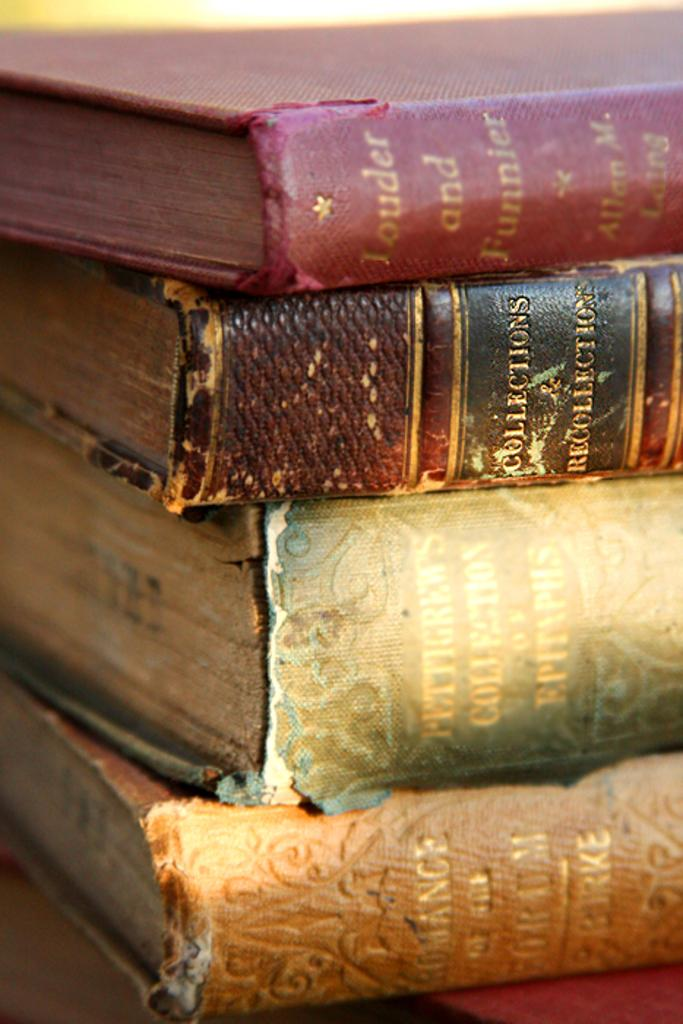<image>
Describe the image concisely. four big books of collection and recollection about funny things 